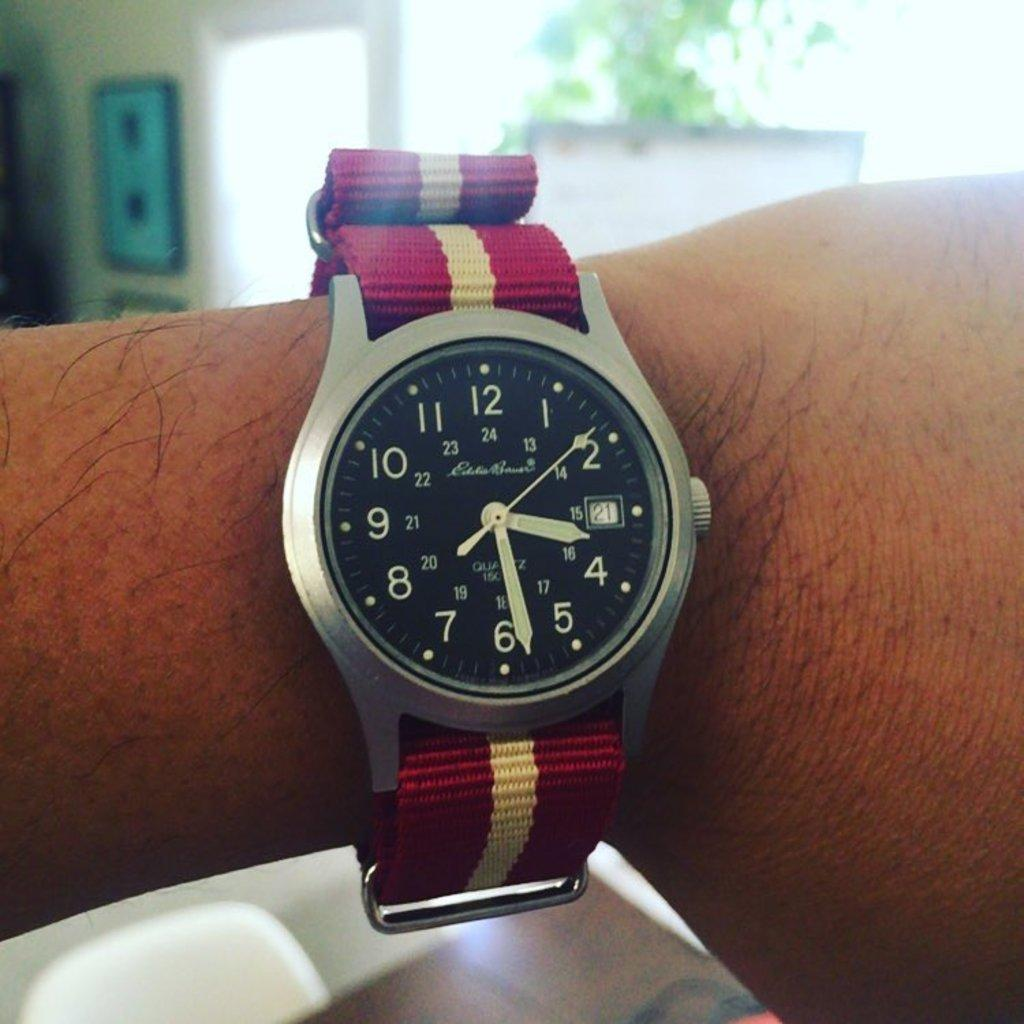Provide a one-sentence caption for the provided image. Silver and black face of a clock which says the number 24 on the top. 